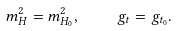<formula> <loc_0><loc_0><loc_500><loc_500>m _ { H } ^ { 2 } = m _ { H _ { 0 } } ^ { 2 } , \quad g _ { t } = g _ { t _ { 0 } } .</formula> 